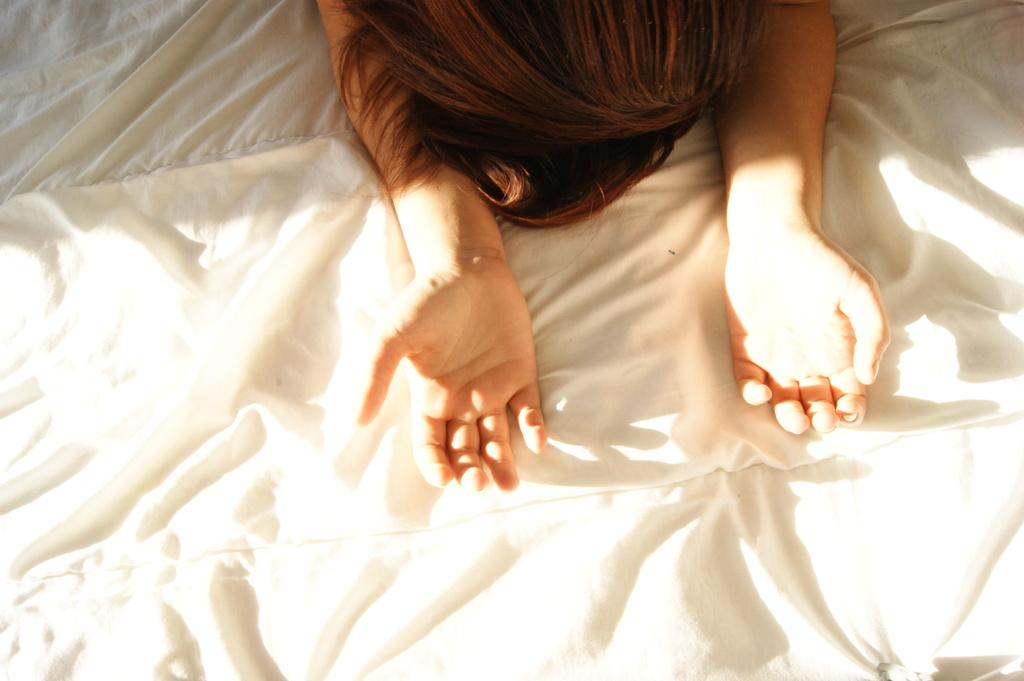What part of a person's body is visible in the image? There is a person's head and hands visible in the image. What color is the cloth that is present in the image? There is a white color cloth in the image. What route does the person in the image take to reach the society? There is no information about a society or a route in the image, so it cannot be determined. 